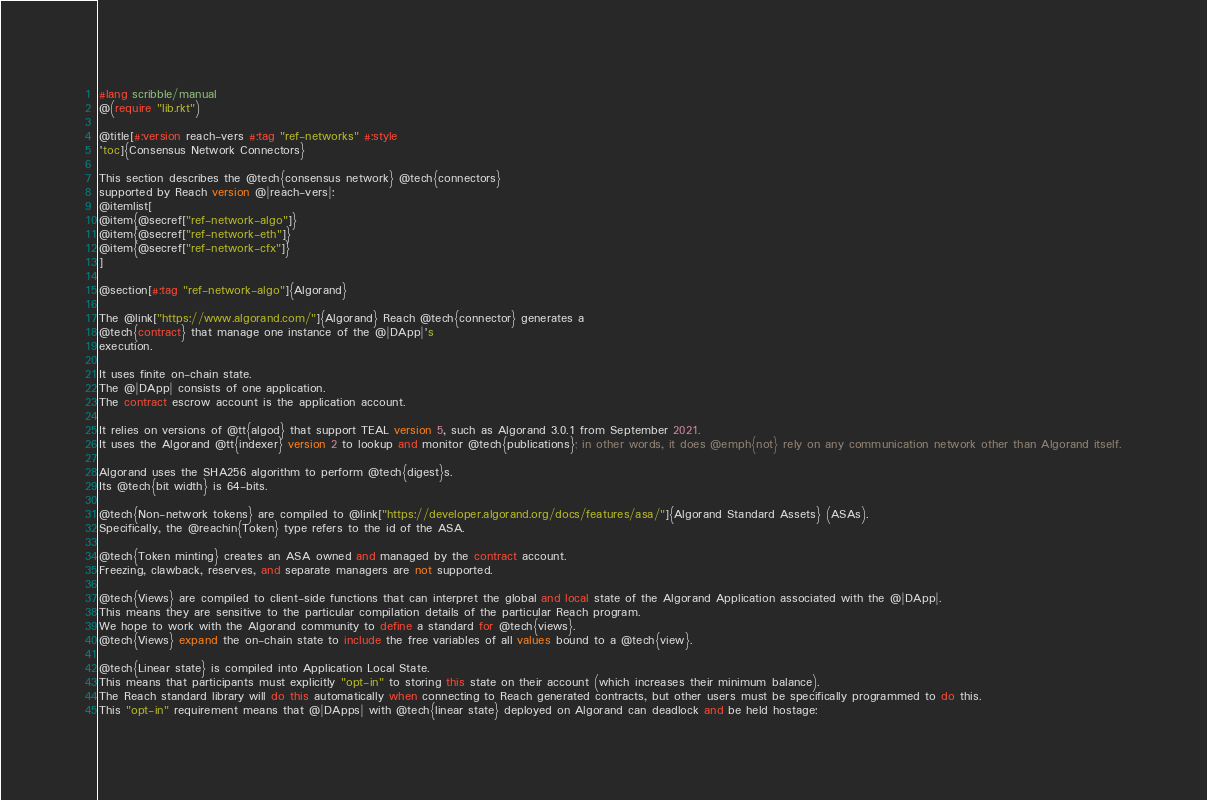<code> <loc_0><loc_0><loc_500><loc_500><_Racket_>#lang scribble/manual
@(require "lib.rkt")

@title[#:version reach-vers #:tag "ref-networks" #:style
'toc]{Consensus Network Connectors}

This section describes the @tech{consensus network} @tech{connectors}
supported by Reach version @|reach-vers|:
@itemlist[
@item{@secref["ref-network-algo"]}
@item{@secref["ref-network-eth"]}
@item{@secref["ref-network-cfx"]}
]

@section[#:tag "ref-network-algo"]{Algorand}

The @link["https://www.algorand.com/"]{Algorand} Reach @tech{connector} generates a
@tech{contract} that manage one instance of the @|DApp|'s
execution.

It uses finite on-chain state.
The @|DApp| consists of one application.
The contract escrow account is the application account.

It relies on versions of @tt{algod} that support TEAL version 5, such as Algorand 3.0.1 from September 2021.
It uses the Algorand @tt{indexer} version 2 to lookup and monitor @tech{publications}; in other words, it does @emph{not} rely on any communication network other than Algorand itself.

Algorand uses the SHA256 algorithm to perform @tech{digest}s.
Its @tech{bit width} is 64-bits.

@tech{Non-network tokens} are compiled to @link["https://developer.algorand.org/docs/features/asa/"]{Algorand Standard Assets} (ASAs).
Specifically, the @reachin{Token} type refers to the id of the ASA.

@tech{Token minting} creates an ASA owned and managed by the contract account.
Freezing, clawback, reserves, and separate managers are not supported.

@tech{Views} are compiled to client-side functions that can interpret the global and local state of the Algorand Application associated with the @|DApp|.
This means they are sensitive to the particular compilation details of the particular Reach program.
We hope to work with the Algorand community to define a standard for @tech{views}.
@tech{Views} expand the on-chain state to include the free variables of all values bound to a @tech{view}.

@tech{Linear state} is compiled into Application Local State.
This means that participants must explicitly "opt-in" to storing this state on their account (which increases their minimum balance).
The Reach standard library will do this automatically when connecting to Reach generated contracts, but other users must be specifically programmed to do this.
This "opt-in" requirement means that @|DApps| with @tech{linear state} deployed on Algorand can deadlock and be held hostage:</code> 